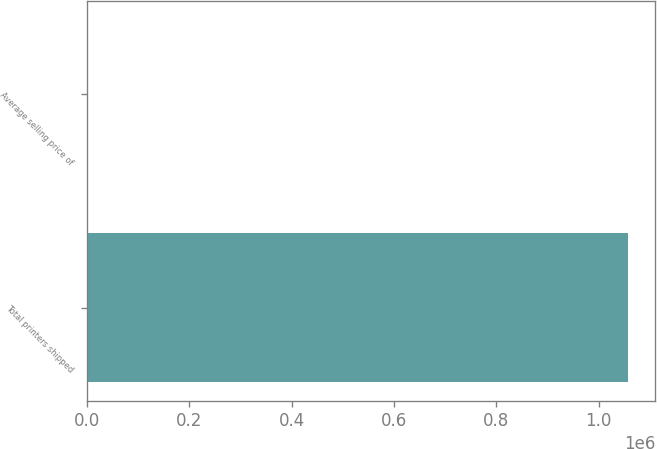Convert chart. <chart><loc_0><loc_0><loc_500><loc_500><bar_chart><fcel>Total printers shipped<fcel>Average selling price of<nl><fcel>1.05774e+06<fcel>533<nl></chart> 